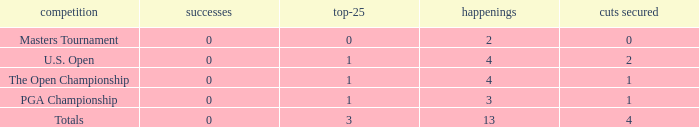How many cuts did he make in the tournament with 3 top 25s and under 13 events? None. 